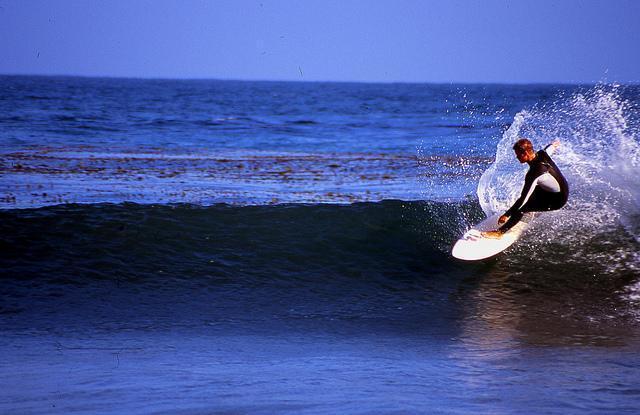How many surfboards are there?
Give a very brief answer. 1. 